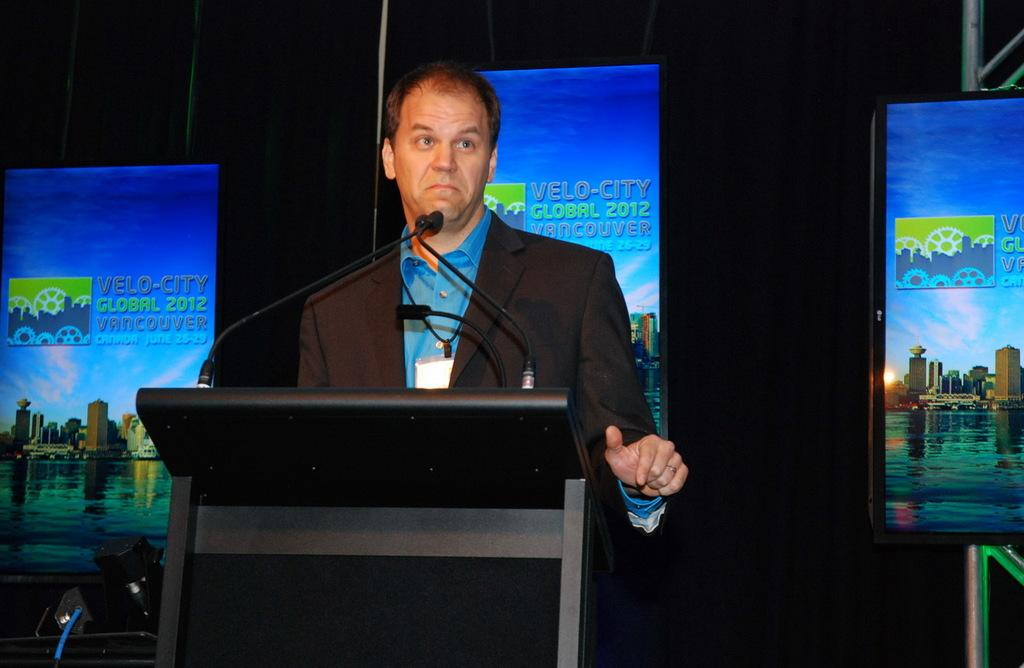<image>
Present a compact description of the photo's key features. a man standing at a podium with an advertisement for velo-city behind him 